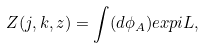<formula> <loc_0><loc_0><loc_500><loc_500>Z ( j , k , z ) = \int ( d \phi _ { A } ) e x p i L ,</formula> 